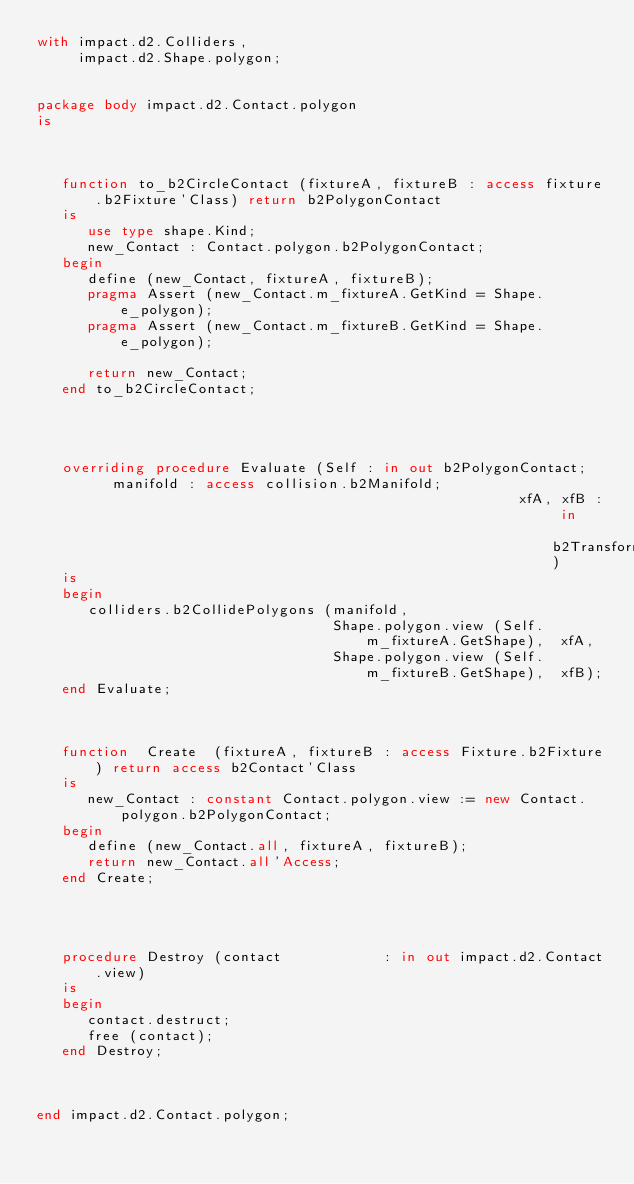Convert code to text. <code><loc_0><loc_0><loc_500><loc_500><_Ada_>with impact.d2.Colliders,
     impact.d2.Shape.polygon;


package body impact.d2.Contact.polygon
is



   function to_b2CircleContact (fixtureA, fixtureB : access fixture.b2Fixture'Class) return b2PolygonContact
   is
      use type shape.Kind;
      new_Contact : Contact.polygon.b2PolygonContact;
   begin
      define (new_Contact, fixtureA, fixtureB);
      pragma Assert (new_Contact.m_fixtureA.GetKind = Shape.e_polygon);
      pragma Assert (new_Contact.m_fixtureB.GetKind = Shape.e_polygon);

      return new_Contact;
   end to_b2CircleContact;




   overriding procedure Evaluate (Self : in out b2PolygonContact;   manifold : access collision.b2Manifold;
                                                         xfA, xfB : in     b2Transform)
   is
   begin
      colliders.b2CollidePolygons (manifold,
                                   Shape.polygon.view (Self.m_fixtureA.GetShape),  xfA,
                                   Shape.polygon.view (Self.m_fixtureB.GetShape),  xfB);
   end Evaluate;



   function  Create  (fixtureA, fixtureB : access Fixture.b2Fixture) return access b2Contact'Class
   is
      new_Contact : constant Contact.polygon.view := new Contact.polygon.b2PolygonContact;
   begin
      define (new_Contact.all, fixtureA, fixtureB);
      return new_Contact.all'Access;
   end Create;




   procedure Destroy (contact            : in out impact.d2.Contact.view)
   is
   begin
      contact.destruct;
      free (contact);
   end Destroy;



end impact.d2.Contact.polygon;
</code> 